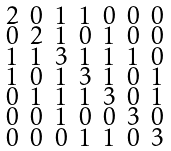Convert formula to latex. <formula><loc_0><loc_0><loc_500><loc_500>\begin{smallmatrix} 2 & 0 & 1 & 1 & 0 & 0 & 0 \\ 0 & 2 & 1 & 0 & 1 & 0 & 0 \\ 1 & 1 & 3 & 1 & 1 & 1 & 0 \\ 1 & 0 & 1 & 3 & 1 & 0 & 1 \\ 0 & 1 & 1 & 1 & 3 & 0 & 1 \\ 0 & 0 & 1 & 0 & 0 & 3 & 0 \\ 0 & 0 & 0 & 1 & 1 & 0 & 3 \end{smallmatrix}</formula> 